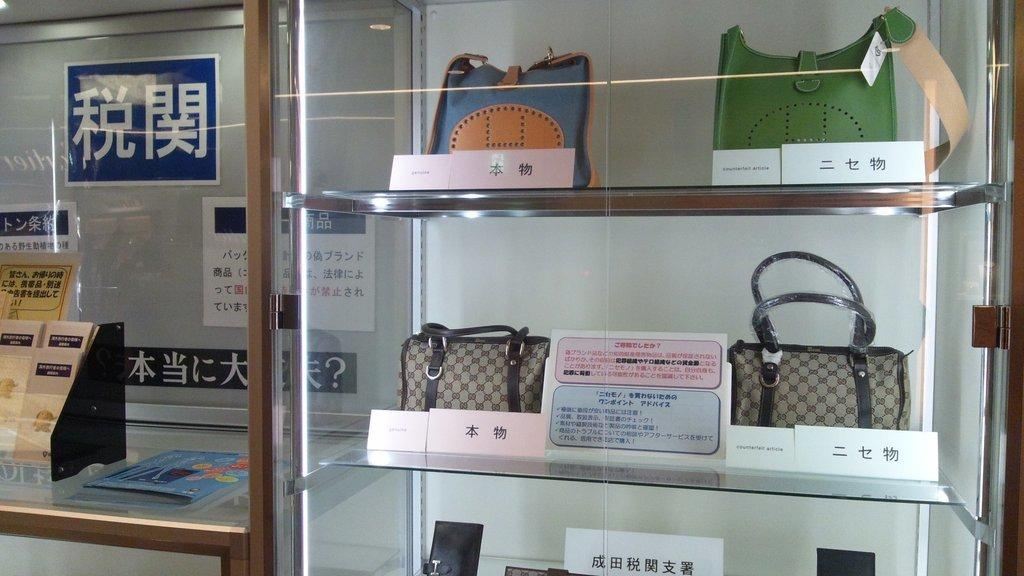What is the main structure in the image? There is a rack in the image. What is placed on the rack? Handbags are placed in the rack. What other objects can be seen in the image? There are boards in the image. Where is the countertop located in the image? There is a countertop on the left side of the image. What is placed on the countertop? There are things placed on the countertop. Can you see any protesters in the image? There are no protesters visible in the image. What type of branch can be seen growing from the countertop? There are no branches present in the image. 